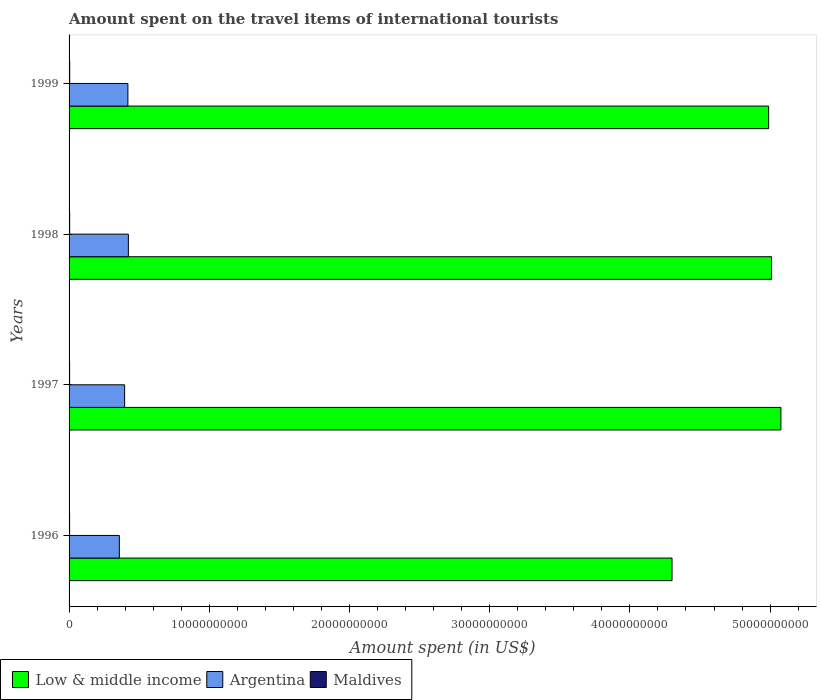How many different coloured bars are there?
Keep it short and to the point. 3. Are the number of bars on each tick of the Y-axis equal?
Your answer should be compact. Yes. How many bars are there on the 1st tick from the top?
Make the answer very short. 3. How many bars are there on the 2nd tick from the bottom?
Your answer should be compact. 3. What is the label of the 4th group of bars from the top?
Your response must be concise. 1996. What is the amount spent on the travel items of international tourists in Low & middle income in 1996?
Provide a short and direct response. 4.30e+1. Across all years, what is the maximum amount spent on the travel items of international tourists in Maldives?
Ensure brevity in your answer.  4.50e+07. Across all years, what is the minimum amount spent on the travel items of international tourists in Low & middle income?
Keep it short and to the point. 4.30e+1. In which year was the amount spent on the travel items of international tourists in Maldives minimum?
Your response must be concise. 1996. What is the total amount spent on the travel items of international tourists in Maldives in the graph?
Keep it short and to the point. 1.65e+08. What is the difference between the amount spent on the travel items of international tourists in Argentina in 1996 and that in 1998?
Keep it short and to the point. -6.46e+08. What is the difference between the amount spent on the travel items of international tourists in Maldives in 1996 and the amount spent on the travel items of international tourists in Low & middle income in 1999?
Give a very brief answer. -4.99e+1. What is the average amount spent on the travel items of international tourists in Argentina per year?
Your answer should be compact. 3.99e+09. In the year 1996, what is the difference between the amount spent on the travel items of international tourists in Argentina and amount spent on the travel items of international tourists in Maldives?
Make the answer very short. 3.55e+09. In how many years, is the amount spent on the travel items of international tourists in Maldives greater than 46000000000 US$?
Make the answer very short. 0. What is the ratio of the amount spent on the travel items of international tourists in Low & middle income in 1996 to that in 1997?
Keep it short and to the point. 0.85. Is the difference between the amount spent on the travel items of international tourists in Argentina in 1996 and 1997 greater than the difference between the amount spent on the travel items of international tourists in Maldives in 1996 and 1997?
Provide a succinct answer. No. What is the difference between the highest and the second highest amount spent on the travel items of international tourists in Argentina?
Provide a succinct answer. 3.50e+07. What is the difference between the highest and the lowest amount spent on the travel items of international tourists in Argentina?
Give a very brief answer. 6.46e+08. In how many years, is the amount spent on the travel items of international tourists in Maldives greater than the average amount spent on the travel items of international tourists in Maldives taken over all years?
Ensure brevity in your answer.  2. Is the sum of the amount spent on the travel items of international tourists in Maldives in 1998 and 1999 greater than the maximum amount spent on the travel items of international tourists in Argentina across all years?
Provide a short and direct response. No. What does the 1st bar from the bottom in 1999 represents?
Make the answer very short. Low & middle income. Is it the case that in every year, the sum of the amount spent on the travel items of international tourists in Low & middle income and amount spent on the travel items of international tourists in Argentina is greater than the amount spent on the travel items of international tourists in Maldives?
Keep it short and to the point. Yes. Does the graph contain any zero values?
Your answer should be very brief. No. Where does the legend appear in the graph?
Give a very brief answer. Bottom left. How many legend labels are there?
Offer a terse response. 3. What is the title of the graph?
Give a very brief answer. Amount spent on the travel items of international tourists. Does "Tanzania" appear as one of the legend labels in the graph?
Your answer should be compact. No. What is the label or title of the X-axis?
Your response must be concise. Amount spent (in US$). What is the label or title of the Y-axis?
Give a very brief answer. Years. What is the Amount spent (in US$) of Low & middle income in 1996?
Your answer should be very brief. 4.30e+1. What is the Amount spent (in US$) of Argentina in 1996?
Ensure brevity in your answer.  3.58e+09. What is the Amount spent (in US$) in Maldives in 1996?
Provide a short and direct response. 3.80e+07. What is the Amount spent (in US$) of Low & middle income in 1997?
Your answer should be compact. 5.08e+1. What is the Amount spent (in US$) of Argentina in 1997?
Provide a succinct answer. 3.96e+09. What is the Amount spent (in US$) in Maldives in 1997?
Ensure brevity in your answer.  4.00e+07. What is the Amount spent (in US$) of Low & middle income in 1998?
Provide a short and direct response. 5.01e+1. What is the Amount spent (in US$) in Argentina in 1998?
Offer a terse response. 4.23e+09. What is the Amount spent (in US$) in Maldives in 1998?
Ensure brevity in your answer.  4.20e+07. What is the Amount spent (in US$) of Low & middle income in 1999?
Give a very brief answer. 4.99e+1. What is the Amount spent (in US$) of Argentina in 1999?
Your answer should be very brief. 4.20e+09. What is the Amount spent (in US$) in Maldives in 1999?
Make the answer very short. 4.50e+07. Across all years, what is the maximum Amount spent (in US$) in Low & middle income?
Ensure brevity in your answer.  5.08e+1. Across all years, what is the maximum Amount spent (in US$) in Argentina?
Make the answer very short. 4.23e+09. Across all years, what is the maximum Amount spent (in US$) of Maldives?
Your response must be concise. 4.50e+07. Across all years, what is the minimum Amount spent (in US$) in Low & middle income?
Provide a succinct answer. 4.30e+1. Across all years, what is the minimum Amount spent (in US$) in Argentina?
Make the answer very short. 3.58e+09. Across all years, what is the minimum Amount spent (in US$) of Maldives?
Offer a terse response. 3.80e+07. What is the total Amount spent (in US$) in Low & middle income in the graph?
Give a very brief answer. 1.94e+11. What is the total Amount spent (in US$) of Argentina in the graph?
Your answer should be very brief. 1.60e+1. What is the total Amount spent (in US$) in Maldives in the graph?
Give a very brief answer. 1.65e+08. What is the difference between the Amount spent (in US$) in Low & middle income in 1996 and that in 1997?
Offer a terse response. -7.77e+09. What is the difference between the Amount spent (in US$) in Argentina in 1996 and that in 1997?
Keep it short and to the point. -3.78e+08. What is the difference between the Amount spent (in US$) in Low & middle income in 1996 and that in 1998?
Offer a terse response. -7.10e+09. What is the difference between the Amount spent (in US$) of Argentina in 1996 and that in 1998?
Offer a very short reply. -6.46e+08. What is the difference between the Amount spent (in US$) in Maldives in 1996 and that in 1998?
Your answer should be compact. -4.00e+06. What is the difference between the Amount spent (in US$) of Low & middle income in 1996 and that in 1999?
Your answer should be compact. -6.89e+09. What is the difference between the Amount spent (in US$) of Argentina in 1996 and that in 1999?
Keep it short and to the point. -6.11e+08. What is the difference between the Amount spent (in US$) in Maldives in 1996 and that in 1999?
Ensure brevity in your answer.  -7.00e+06. What is the difference between the Amount spent (in US$) of Low & middle income in 1997 and that in 1998?
Your answer should be compact. 6.66e+08. What is the difference between the Amount spent (in US$) in Argentina in 1997 and that in 1998?
Give a very brief answer. -2.68e+08. What is the difference between the Amount spent (in US$) in Maldives in 1997 and that in 1998?
Your answer should be compact. -2.00e+06. What is the difference between the Amount spent (in US$) in Low & middle income in 1997 and that in 1999?
Make the answer very short. 8.75e+08. What is the difference between the Amount spent (in US$) in Argentina in 1997 and that in 1999?
Offer a very short reply. -2.33e+08. What is the difference between the Amount spent (in US$) in Maldives in 1997 and that in 1999?
Ensure brevity in your answer.  -5.00e+06. What is the difference between the Amount spent (in US$) of Low & middle income in 1998 and that in 1999?
Your answer should be compact. 2.08e+08. What is the difference between the Amount spent (in US$) of Argentina in 1998 and that in 1999?
Your answer should be compact. 3.50e+07. What is the difference between the Amount spent (in US$) in Maldives in 1998 and that in 1999?
Give a very brief answer. -3.00e+06. What is the difference between the Amount spent (in US$) of Low & middle income in 1996 and the Amount spent (in US$) of Argentina in 1997?
Provide a short and direct response. 3.90e+1. What is the difference between the Amount spent (in US$) of Low & middle income in 1996 and the Amount spent (in US$) of Maldives in 1997?
Make the answer very short. 4.30e+1. What is the difference between the Amount spent (in US$) in Argentina in 1996 and the Amount spent (in US$) in Maldives in 1997?
Keep it short and to the point. 3.54e+09. What is the difference between the Amount spent (in US$) of Low & middle income in 1996 and the Amount spent (in US$) of Argentina in 1998?
Your response must be concise. 3.88e+1. What is the difference between the Amount spent (in US$) in Low & middle income in 1996 and the Amount spent (in US$) in Maldives in 1998?
Make the answer very short. 4.30e+1. What is the difference between the Amount spent (in US$) in Argentina in 1996 and the Amount spent (in US$) in Maldives in 1998?
Your answer should be very brief. 3.54e+09. What is the difference between the Amount spent (in US$) of Low & middle income in 1996 and the Amount spent (in US$) of Argentina in 1999?
Your answer should be very brief. 3.88e+1. What is the difference between the Amount spent (in US$) in Low & middle income in 1996 and the Amount spent (in US$) in Maldives in 1999?
Your answer should be very brief. 4.30e+1. What is the difference between the Amount spent (in US$) of Argentina in 1996 and the Amount spent (in US$) of Maldives in 1999?
Provide a short and direct response. 3.54e+09. What is the difference between the Amount spent (in US$) of Low & middle income in 1997 and the Amount spent (in US$) of Argentina in 1998?
Your response must be concise. 4.65e+1. What is the difference between the Amount spent (in US$) in Low & middle income in 1997 and the Amount spent (in US$) in Maldives in 1998?
Offer a terse response. 5.07e+1. What is the difference between the Amount spent (in US$) in Argentina in 1997 and the Amount spent (in US$) in Maldives in 1998?
Ensure brevity in your answer.  3.92e+09. What is the difference between the Amount spent (in US$) in Low & middle income in 1997 and the Amount spent (in US$) in Argentina in 1999?
Offer a terse response. 4.66e+1. What is the difference between the Amount spent (in US$) of Low & middle income in 1997 and the Amount spent (in US$) of Maldives in 1999?
Keep it short and to the point. 5.07e+1. What is the difference between the Amount spent (in US$) in Argentina in 1997 and the Amount spent (in US$) in Maldives in 1999?
Your answer should be very brief. 3.92e+09. What is the difference between the Amount spent (in US$) of Low & middle income in 1998 and the Amount spent (in US$) of Argentina in 1999?
Your answer should be compact. 4.59e+1. What is the difference between the Amount spent (in US$) of Low & middle income in 1998 and the Amount spent (in US$) of Maldives in 1999?
Provide a succinct answer. 5.01e+1. What is the difference between the Amount spent (in US$) of Argentina in 1998 and the Amount spent (in US$) of Maldives in 1999?
Your answer should be very brief. 4.18e+09. What is the average Amount spent (in US$) in Low & middle income per year?
Provide a succinct answer. 4.84e+1. What is the average Amount spent (in US$) in Argentina per year?
Provide a short and direct response. 3.99e+09. What is the average Amount spent (in US$) of Maldives per year?
Make the answer very short. 4.12e+07. In the year 1996, what is the difference between the Amount spent (in US$) in Low & middle income and Amount spent (in US$) in Argentina?
Offer a very short reply. 3.94e+1. In the year 1996, what is the difference between the Amount spent (in US$) of Low & middle income and Amount spent (in US$) of Maldives?
Offer a terse response. 4.30e+1. In the year 1996, what is the difference between the Amount spent (in US$) of Argentina and Amount spent (in US$) of Maldives?
Provide a succinct answer. 3.55e+09. In the year 1997, what is the difference between the Amount spent (in US$) in Low & middle income and Amount spent (in US$) in Argentina?
Provide a succinct answer. 4.68e+1. In the year 1997, what is the difference between the Amount spent (in US$) in Low & middle income and Amount spent (in US$) in Maldives?
Provide a short and direct response. 5.07e+1. In the year 1997, what is the difference between the Amount spent (in US$) in Argentina and Amount spent (in US$) in Maldives?
Offer a terse response. 3.92e+09. In the year 1998, what is the difference between the Amount spent (in US$) of Low & middle income and Amount spent (in US$) of Argentina?
Provide a short and direct response. 4.59e+1. In the year 1998, what is the difference between the Amount spent (in US$) of Low & middle income and Amount spent (in US$) of Maldives?
Ensure brevity in your answer.  5.01e+1. In the year 1998, what is the difference between the Amount spent (in US$) in Argentina and Amount spent (in US$) in Maldives?
Your answer should be compact. 4.19e+09. In the year 1999, what is the difference between the Amount spent (in US$) in Low & middle income and Amount spent (in US$) in Argentina?
Your response must be concise. 4.57e+1. In the year 1999, what is the difference between the Amount spent (in US$) of Low & middle income and Amount spent (in US$) of Maldives?
Keep it short and to the point. 4.99e+1. In the year 1999, what is the difference between the Amount spent (in US$) of Argentina and Amount spent (in US$) of Maldives?
Your answer should be compact. 4.15e+09. What is the ratio of the Amount spent (in US$) of Low & middle income in 1996 to that in 1997?
Offer a very short reply. 0.85. What is the ratio of the Amount spent (in US$) in Argentina in 1996 to that in 1997?
Ensure brevity in your answer.  0.9. What is the ratio of the Amount spent (in US$) of Maldives in 1996 to that in 1997?
Provide a succinct answer. 0.95. What is the ratio of the Amount spent (in US$) of Low & middle income in 1996 to that in 1998?
Keep it short and to the point. 0.86. What is the ratio of the Amount spent (in US$) of Argentina in 1996 to that in 1998?
Your answer should be compact. 0.85. What is the ratio of the Amount spent (in US$) in Maldives in 1996 to that in 1998?
Give a very brief answer. 0.9. What is the ratio of the Amount spent (in US$) of Low & middle income in 1996 to that in 1999?
Your answer should be compact. 0.86. What is the ratio of the Amount spent (in US$) of Argentina in 1996 to that in 1999?
Keep it short and to the point. 0.85. What is the ratio of the Amount spent (in US$) in Maldives in 1996 to that in 1999?
Offer a terse response. 0.84. What is the ratio of the Amount spent (in US$) of Low & middle income in 1997 to that in 1998?
Give a very brief answer. 1.01. What is the ratio of the Amount spent (in US$) of Argentina in 1997 to that in 1998?
Your response must be concise. 0.94. What is the ratio of the Amount spent (in US$) of Maldives in 1997 to that in 1998?
Your response must be concise. 0.95. What is the ratio of the Amount spent (in US$) in Low & middle income in 1997 to that in 1999?
Provide a succinct answer. 1.02. What is the ratio of the Amount spent (in US$) in Argentina in 1997 to that in 1999?
Make the answer very short. 0.94. What is the ratio of the Amount spent (in US$) of Maldives in 1997 to that in 1999?
Keep it short and to the point. 0.89. What is the ratio of the Amount spent (in US$) of Argentina in 1998 to that in 1999?
Offer a terse response. 1.01. What is the ratio of the Amount spent (in US$) in Maldives in 1998 to that in 1999?
Your answer should be compact. 0.93. What is the difference between the highest and the second highest Amount spent (in US$) of Low & middle income?
Your answer should be compact. 6.66e+08. What is the difference between the highest and the second highest Amount spent (in US$) in Argentina?
Your answer should be very brief. 3.50e+07. What is the difference between the highest and the lowest Amount spent (in US$) in Low & middle income?
Ensure brevity in your answer.  7.77e+09. What is the difference between the highest and the lowest Amount spent (in US$) of Argentina?
Your answer should be very brief. 6.46e+08. What is the difference between the highest and the lowest Amount spent (in US$) of Maldives?
Your answer should be very brief. 7.00e+06. 